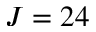<formula> <loc_0><loc_0><loc_500><loc_500>J = 2 4</formula> 